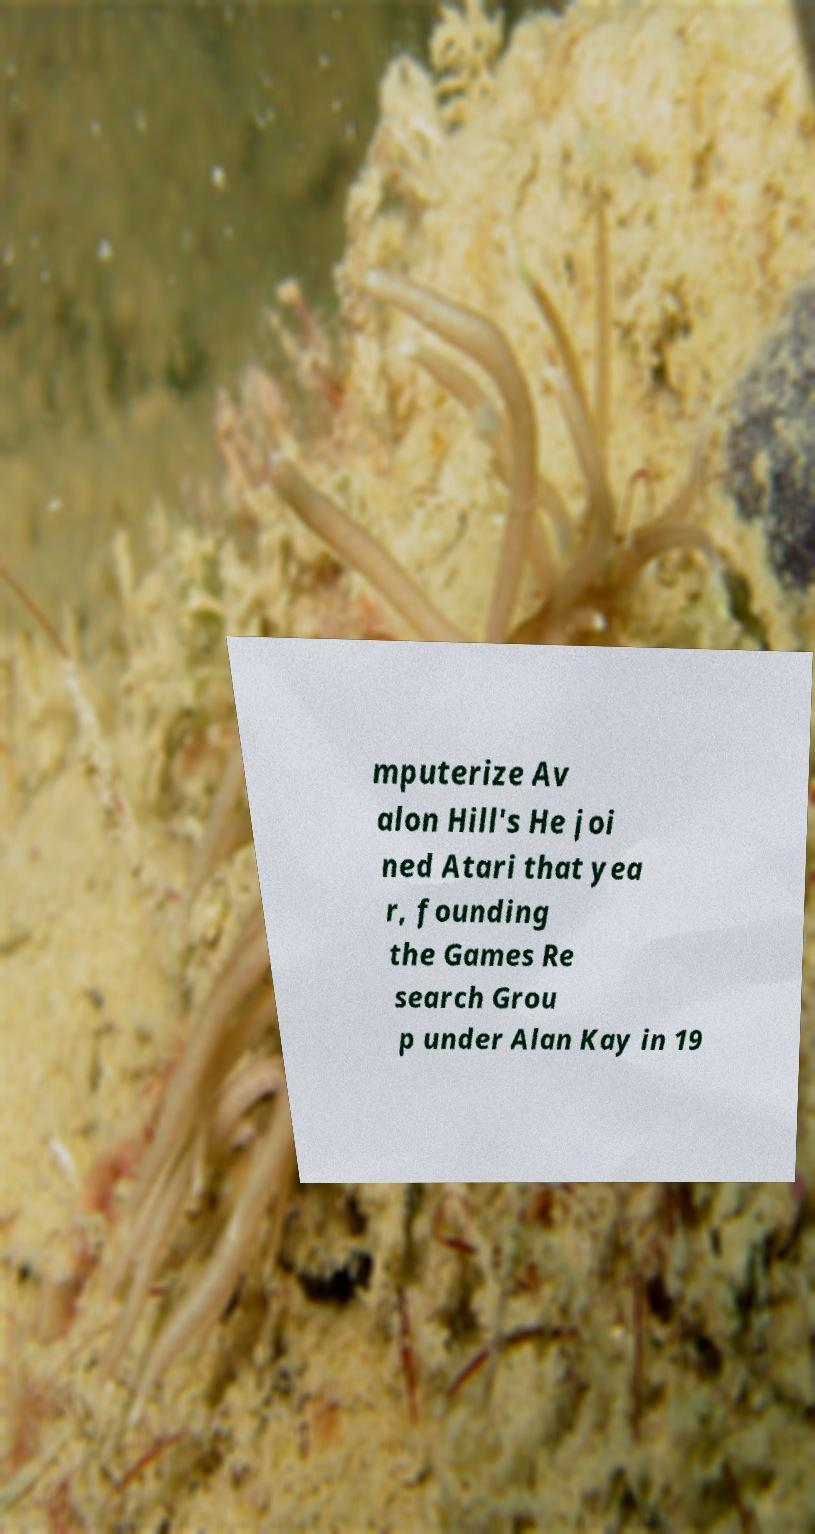Could you assist in decoding the text presented in this image and type it out clearly? mputerize Av alon Hill's He joi ned Atari that yea r, founding the Games Re search Grou p under Alan Kay in 19 